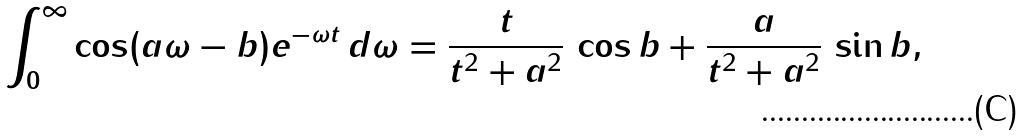<formula> <loc_0><loc_0><loc_500><loc_500>\int _ { 0 } ^ { \infty } \cos ( a \omega - b ) e ^ { - \omega t } \, d \omega = \frac { t } { t ^ { 2 } + a ^ { 2 } } \, \cos b + \frac { a } { t ^ { 2 } + a ^ { 2 } } \, \sin b ,</formula> 